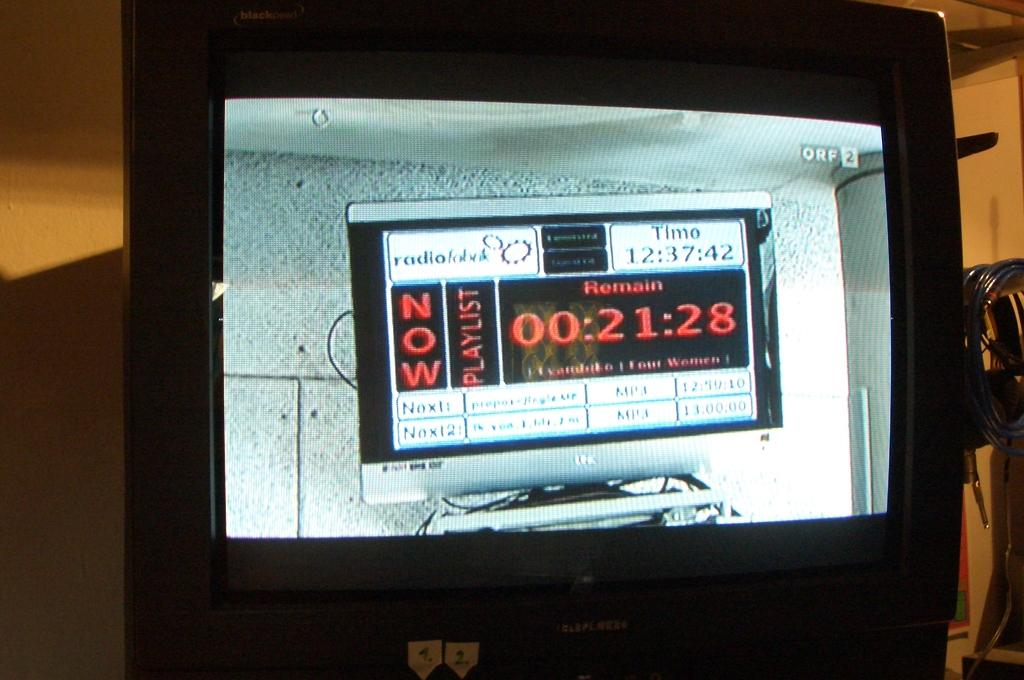<image>
Render a clear and concise summary of the photo. A tv displays another screen with the time 12:37:42. 